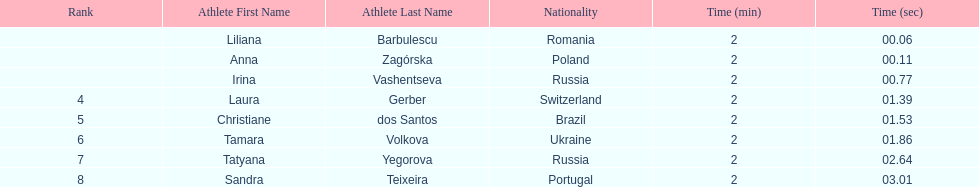The last runner crossed the finish line in 2:03.01. what was the previous time for the 7th runner? 2:02.64. 